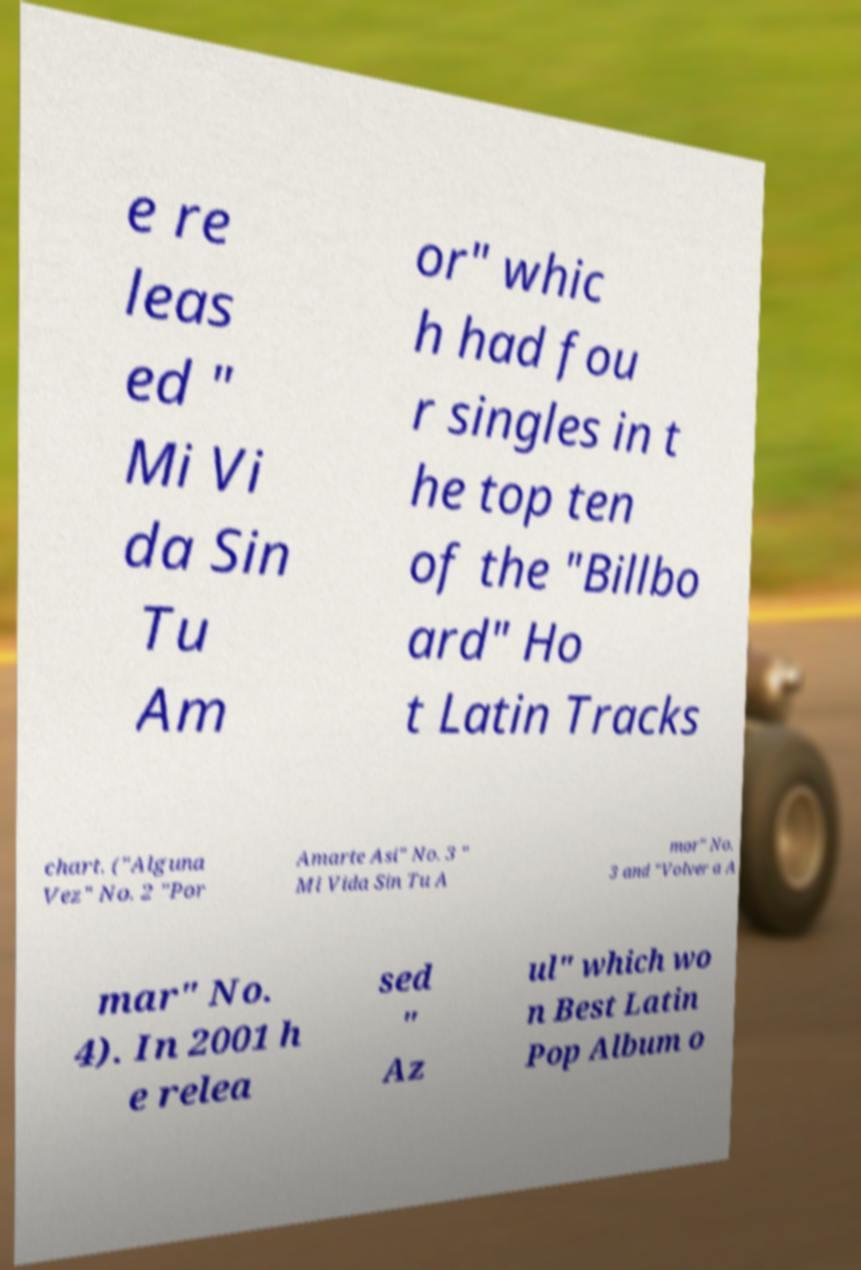For documentation purposes, I need the text within this image transcribed. Could you provide that? e re leas ed " Mi Vi da Sin Tu Am or" whic h had fou r singles in t he top ten of the "Billbo ard" Ho t Latin Tracks chart. ("Alguna Vez" No. 2 "Por Amarte Asi" No. 3 " Mi Vida Sin Tu A mor" No. 3 and "Volver a A mar" No. 4). In 2001 h e relea sed " Az ul" which wo n Best Latin Pop Album o 